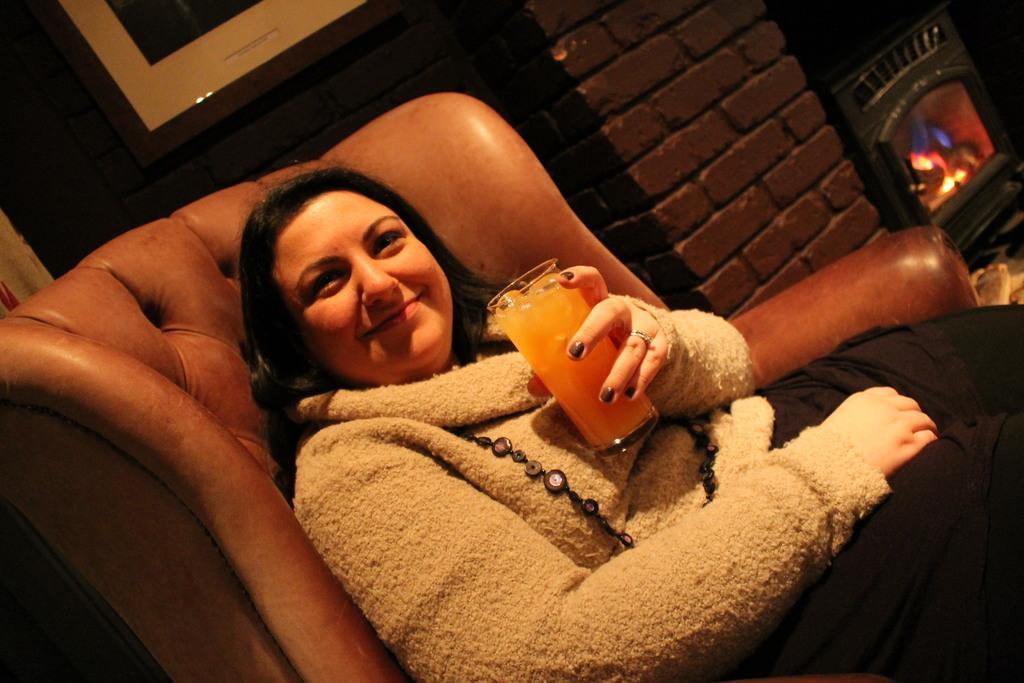Could you give a brief overview of what you see in this image? This picture is taken inside the room. In this image, in the middle, we can see a woman sitting on the couch and she is holding a juice glass in her hand. On the right side, we can see a fire and a brick wall. In the background, we can see a photo frame which is attached to a wall. 